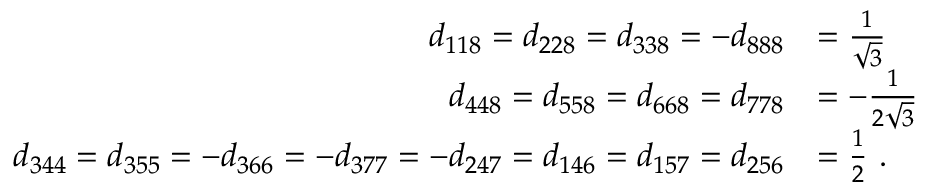Convert formula to latex. <formula><loc_0><loc_0><loc_500><loc_500>{ \begin{array} { r l } { d _ { 1 1 8 } = d _ { 2 2 8 } = d _ { 3 3 8 } = - d _ { 8 8 8 } } & { = { \frac { 1 } { \sqrt { 3 } } } } \\ { d _ { 4 4 8 } = d _ { 5 5 8 } = d _ { 6 6 8 } = d _ { 7 7 8 } } & { = - { \frac { 1 } { 2 { \sqrt { 3 } } } } } \\ { d _ { 3 4 4 } = d _ { 3 5 5 } = - d _ { 3 6 6 } = - d _ { 3 7 7 } = - d _ { 2 4 7 } = d _ { 1 4 6 } = d _ { 1 5 7 } = d _ { 2 5 6 } } & { = { \frac { 1 } { 2 } } . } \end{array} }</formula> 